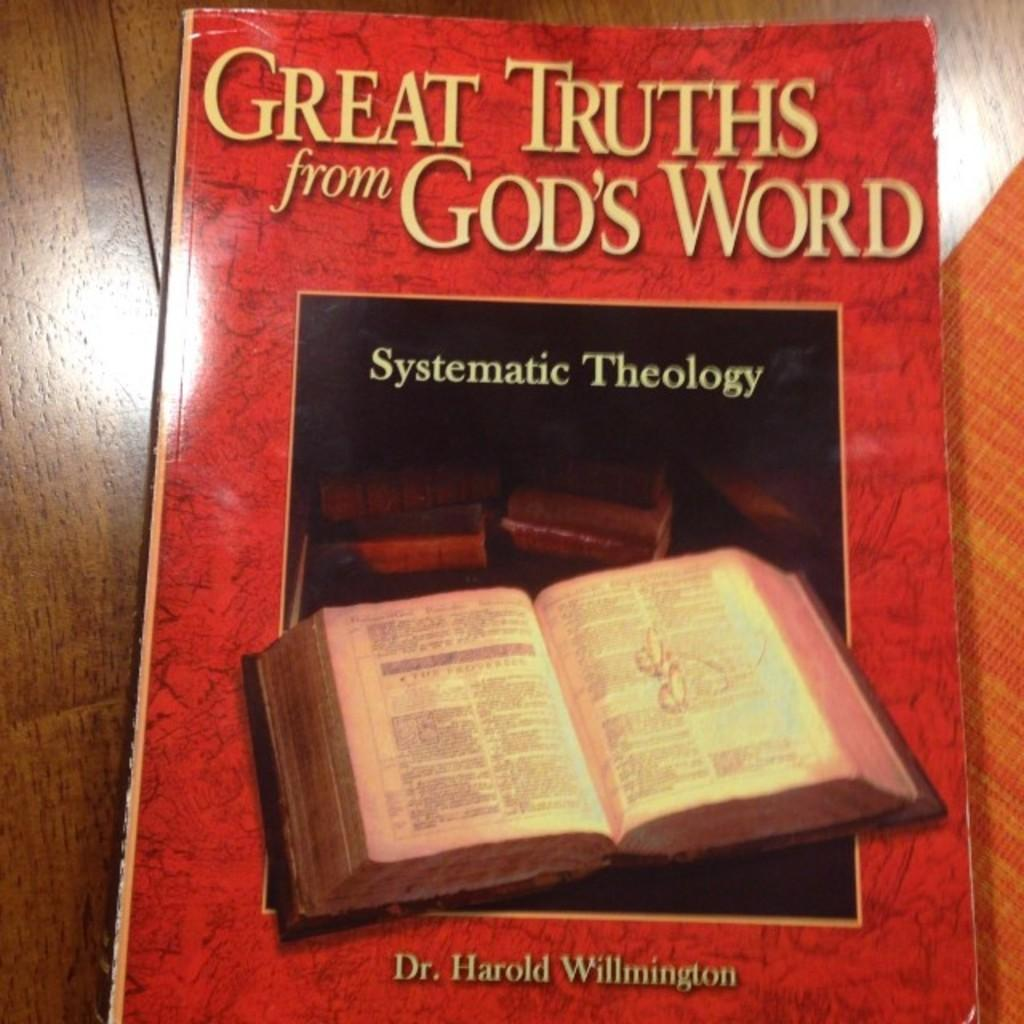What type of furniture is present in the image? There is a table in the image. What object is placed on the table? There is a book on the table. What is the primary content of the book? The book contains text. Does the book also contain any visual elements? Yes, the book contains an image. How often does the book get updated with new content during the week? The frequency of updates to the book's content is not mentioned in the image, and therefore cannot be determined. What type of cord is connected to the book in the image? There is no cord connected to the book in the image. 